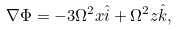<formula> <loc_0><loc_0><loc_500><loc_500>\nabla \Phi = - 3 \Omega ^ { 2 } x { \hat { i } } + \Omega ^ { 2 } z { \hat { k } } ,</formula> 